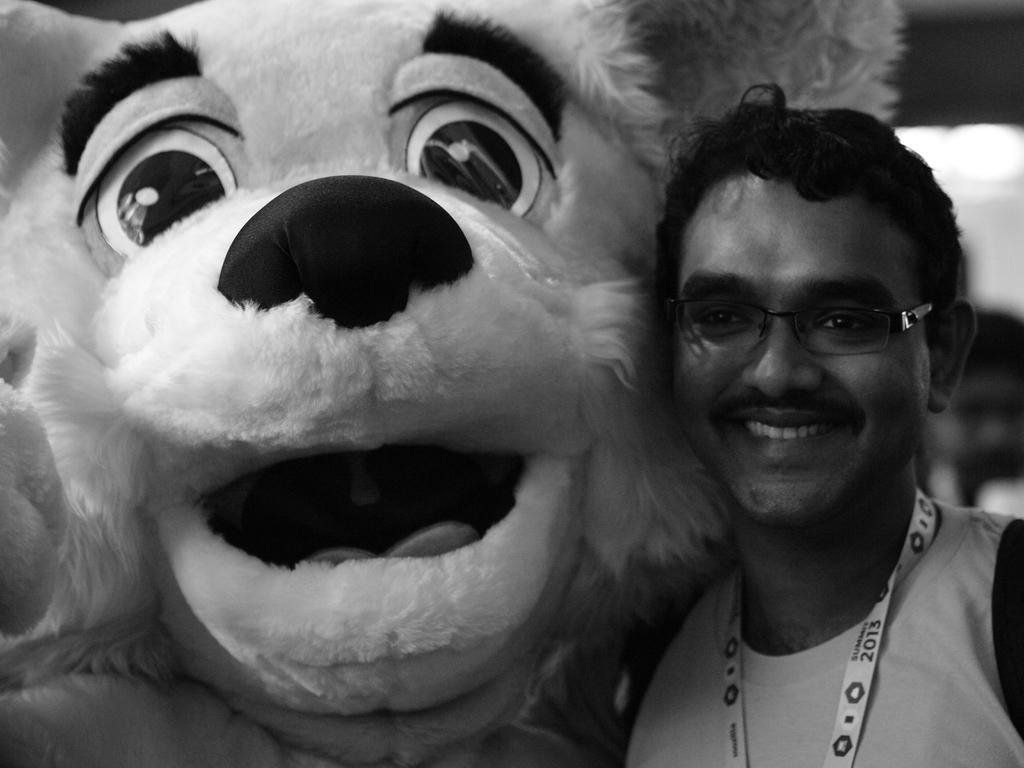What is the man in the image doing? The man in the image is standing and smiling. Can you describe the man's appearance? The man is wearing glasses. Who or what is next to the man? There is a clown next to the man. What type of distribution system is being used by the clown in the image? There is no distribution system present in the image, as it features a man standing and smiling with a clown next to him. 